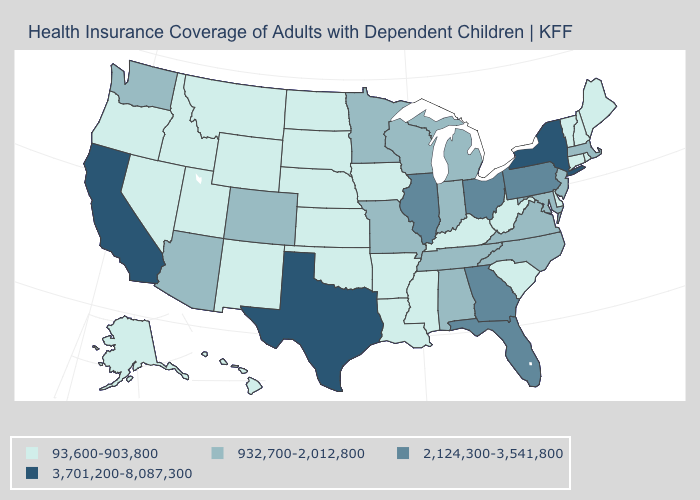Does Kansas have the highest value in the MidWest?
Quick response, please. No. What is the value of Missouri?
Be succinct. 932,700-2,012,800. Does New Jersey have a higher value than Utah?
Be succinct. Yes. How many symbols are there in the legend?
Concise answer only. 4. What is the value of Iowa?
Be succinct. 93,600-903,800. What is the highest value in the West ?
Quick response, please. 3,701,200-8,087,300. Name the states that have a value in the range 2,124,300-3,541,800?
Answer briefly. Florida, Georgia, Illinois, Ohio, Pennsylvania. What is the value of Michigan?
Be succinct. 932,700-2,012,800. How many symbols are there in the legend?
Keep it brief. 4. Does Arkansas have the highest value in the USA?
Short answer required. No. What is the value of Michigan?
Keep it brief. 932,700-2,012,800. Does Illinois have the same value as North Dakota?
Answer briefly. No. Does the map have missing data?
Concise answer only. No. What is the value of Iowa?
Short answer required. 93,600-903,800. Does the first symbol in the legend represent the smallest category?
Keep it brief. Yes. 